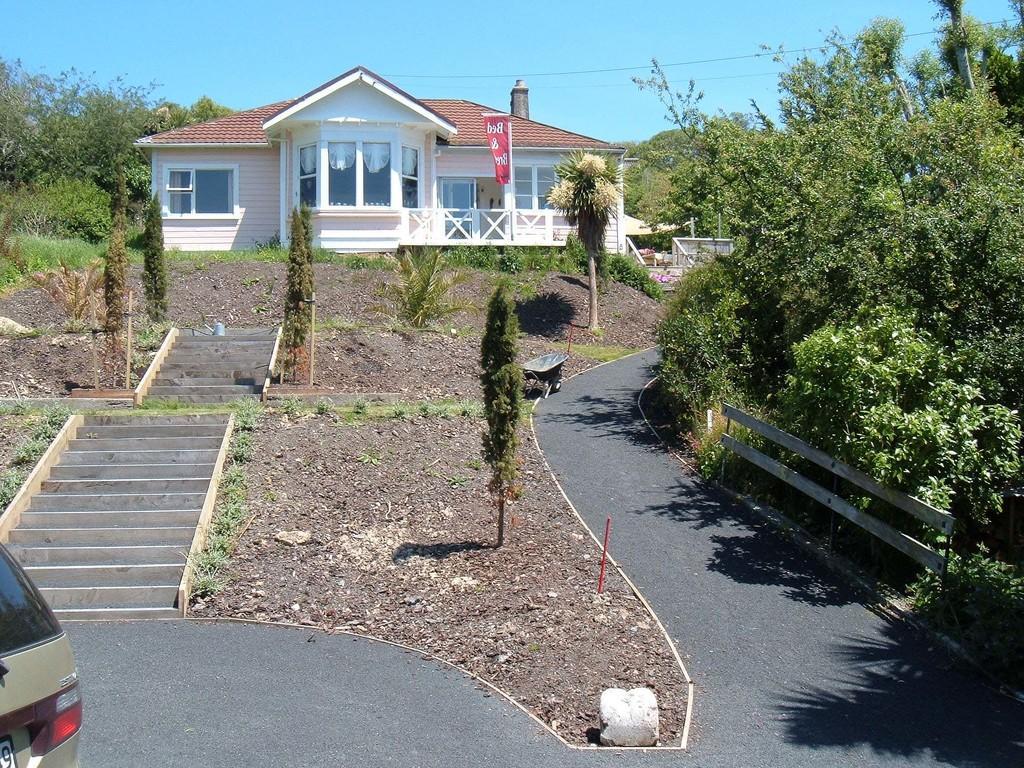Could you give a brief overview of what you see in this image? In the image there is a home in the back with trees and plants on either side of it and steps in the middle followed by a road with a car on it. 